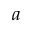<formula> <loc_0><loc_0><loc_500><loc_500>a</formula> 